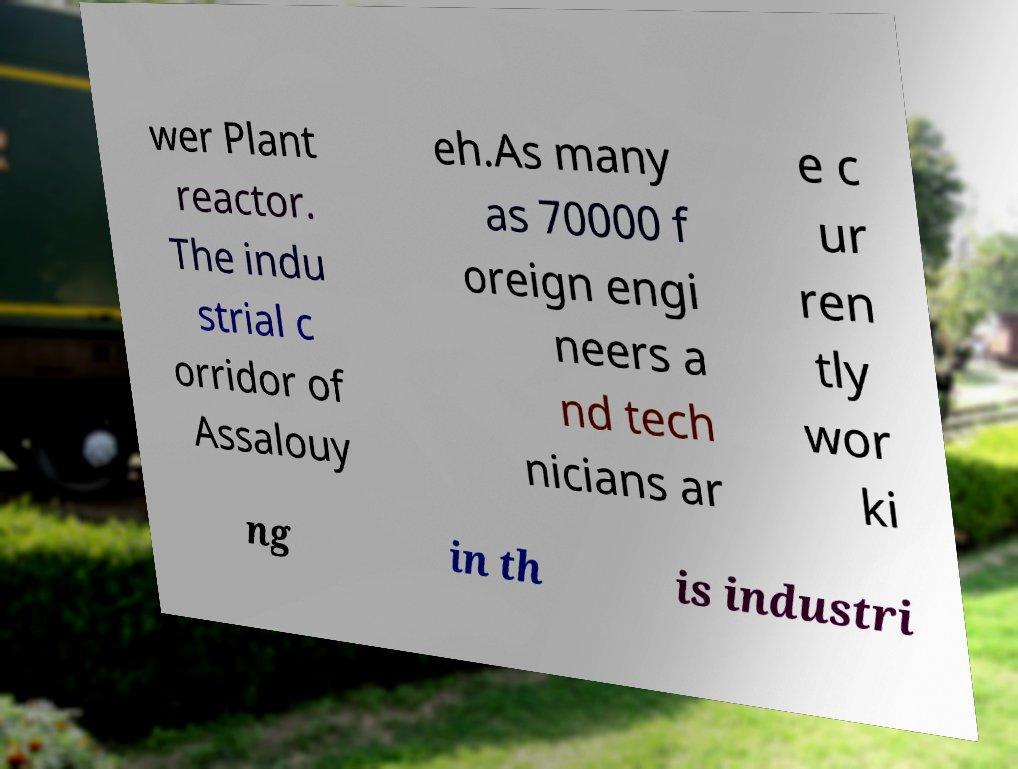There's text embedded in this image that I need extracted. Can you transcribe it verbatim? wer Plant reactor. The indu strial c orridor of Assalouy eh.As many as 70000 f oreign engi neers a nd tech nicians ar e c ur ren tly wor ki ng in th is industri 